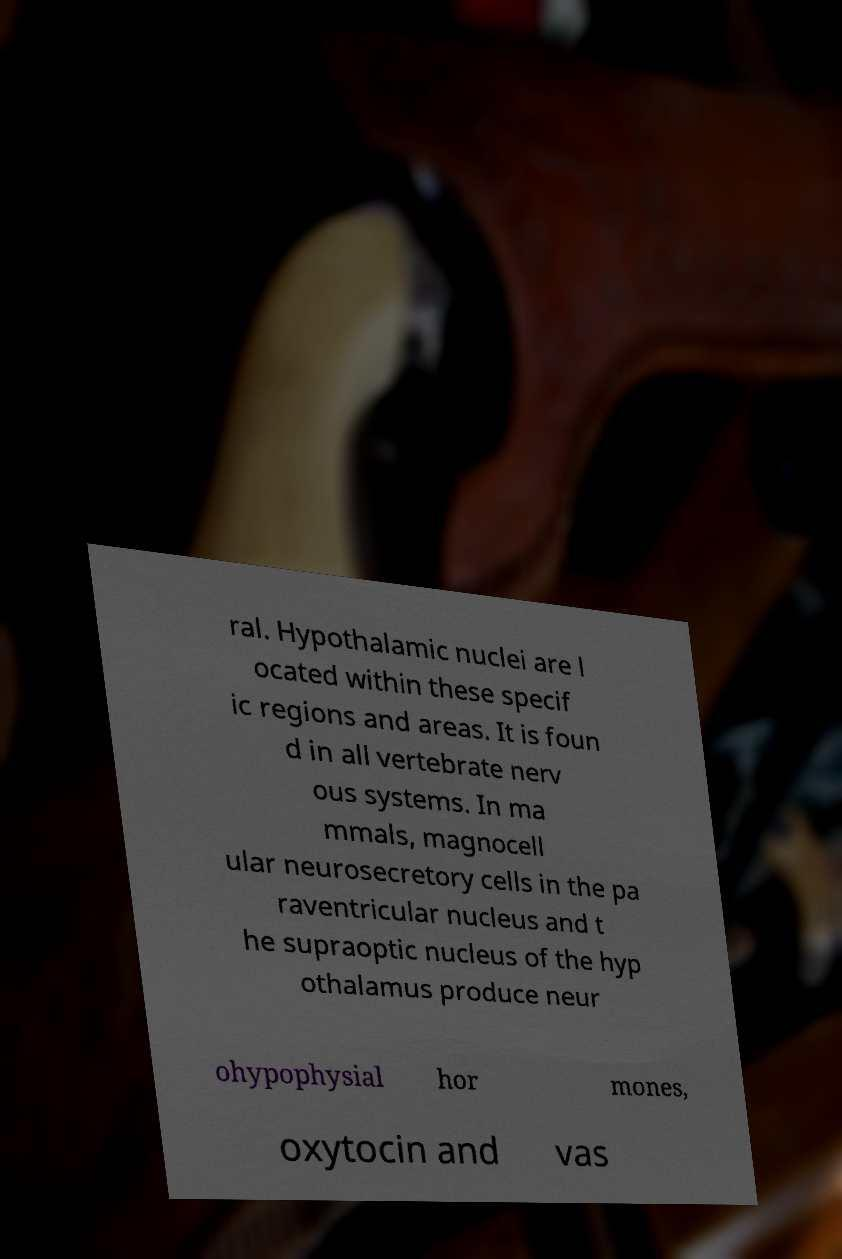For documentation purposes, I need the text within this image transcribed. Could you provide that? ral. Hypothalamic nuclei are l ocated within these specif ic regions and areas. It is foun d in all vertebrate nerv ous systems. In ma mmals, magnocell ular neurosecretory cells in the pa raventricular nucleus and t he supraoptic nucleus of the hyp othalamus produce neur ohypophysial hor mones, oxytocin and vas 